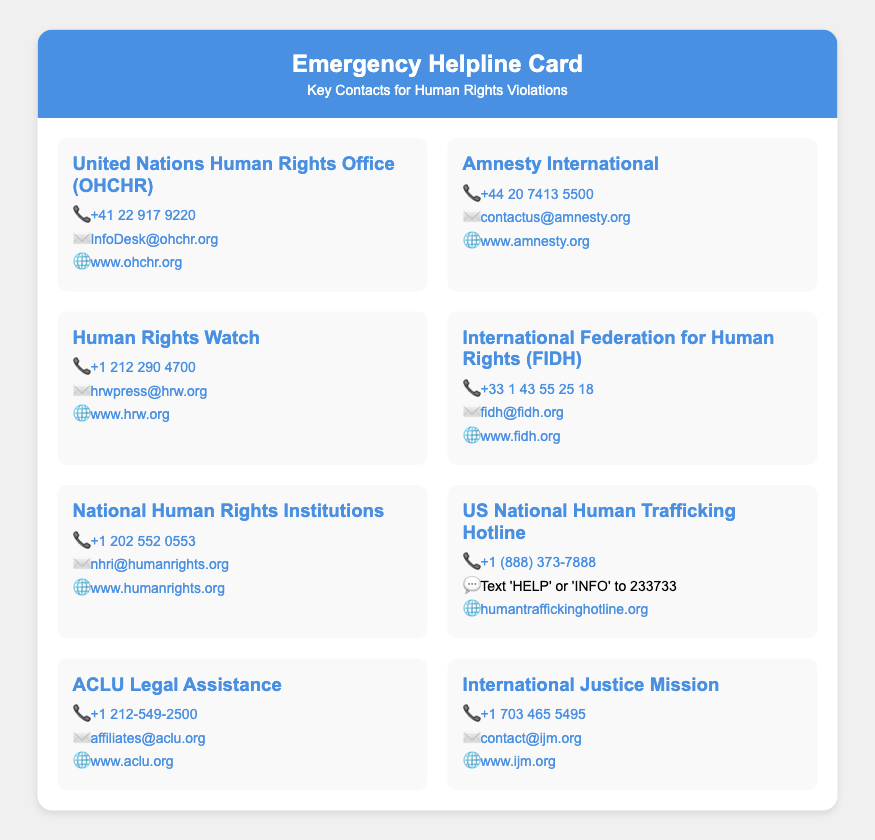what is the title of the document? The title of the document is prominently displayed in the header section, reading "Emergency Helpline Card."
Answer: Emergency Helpline Card who can be contacted at +41 22 917 9220? This phone number belongs to the United Nations Human Rights Office, which is listed in the document.
Answer: United Nations Human Rights Office (OHCHR) what organization is associated with the email InfoDesk@ohchr.org? The email provided corresponds to the United Nations Human Rights Office, indicating how to contact them for inquiries.
Answer: United Nations Human Rights Office (OHCHR) how many organizations are listed in the contact section? The document presents a total of eight organizations for contact regarding human rights violations.
Answer: 8 what does the US National Human Trafficking Hotline number start with? The number for the US National Human Trafficking Hotline begins with the area code +1, indicating a U.S. phone number.
Answer: +1 which organization provides help for legal assistance? According to the document, the ACLU offers legal assistance as indicated by its listing.
Answer: ACLU Legal Assistance what unique identification does the US National Human Trafficking Hotline offer for text messaging? The document specifies a text option allowing individuals to text 'HELP' or 'INFO' for assistance.
Answer: HELP or INFO which website can be visited for more information about Human Rights Watch? The website for Human Rights Watch is provided in the document as a reliable source for further information.
Answer: www.hrw.org 